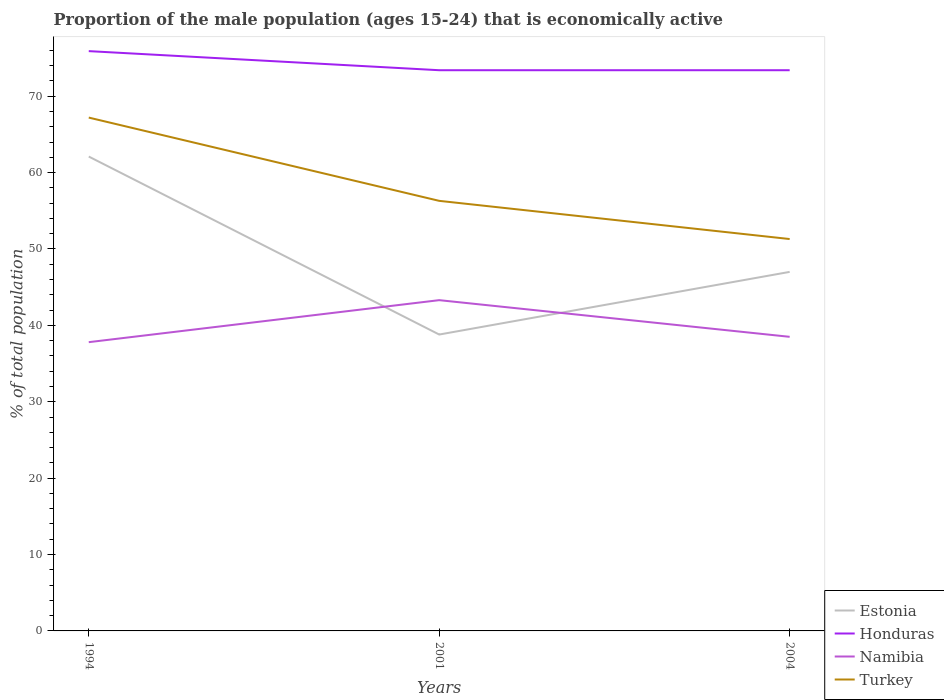How many different coloured lines are there?
Ensure brevity in your answer.  4. Across all years, what is the maximum proportion of the male population that is economically active in Namibia?
Provide a short and direct response. 37.8. In which year was the proportion of the male population that is economically active in Turkey maximum?
Make the answer very short. 2004. What is the difference between the highest and the second highest proportion of the male population that is economically active in Namibia?
Keep it short and to the point. 5.5. How many years are there in the graph?
Offer a terse response. 3. What is the difference between two consecutive major ticks on the Y-axis?
Keep it short and to the point. 10. Does the graph contain any zero values?
Provide a succinct answer. No. How many legend labels are there?
Make the answer very short. 4. How are the legend labels stacked?
Your response must be concise. Vertical. What is the title of the graph?
Your answer should be very brief. Proportion of the male population (ages 15-24) that is economically active. What is the label or title of the X-axis?
Give a very brief answer. Years. What is the label or title of the Y-axis?
Provide a succinct answer. % of total population. What is the % of total population in Estonia in 1994?
Provide a short and direct response. 62.1. What is the % of total population in Honduras in 1994?
Your response must be concise. 75.9. What is the % of total population of Namibia in 1994?
Your answer should be compact. 37.8. What is the % of total population of Turkey in 1994?
Your answer should be compact. 67.2. What is the % of total population of Estonia in 2001?
Offer a terse response. 38.8. What is the % of total population of Honduras in 2001?
Provide a succinct answer. 73.4. What is the % of total population of Namibia in 2001?
Your answer should be compact. 43.3. What is the % of total population of Turkey in 2001?
Make the answer very short. 56.3. What is the % of total population in Estonia in 2004?
Provide a short and direct response. 47. What is the % of total population of Honduras in 2004?
Your answer should be compact. 73.4. What is the % of total population of Namibia in 2004?
Make the answer very short. 38.5. What is the % of total population of Turkey in 2004?
Keep it short and to the point. 51.3. Across all years, what is the maximum % of total population of Estonia?
Provide a succinct answer. 62.1. Across all years, what is the maximum % of total population in Honduras?
Ensure brevity in your answer.  75.9. Across all years, what is the maximum % of total population of Namibia?
Keep it short and to the point. 43.3. Across all years, what is the maximum % of total population in Turkey?
Ensure brevity in your answer.  67.2. Across all years, what is the minimum % of total population of Estonia?
Offer a very short reply. 38.8. Across all years, what is the minimum % of total population in Honduras?
Keep it short and to the point. 73.4. Across all years, what is the minimum % of total population of Namibia?
Offer a terse response. 37.8. Across all years, what is the minimum % of total population of Turkey?
Your answer should be compact. 51.3. What is the total % of total population of Estonia in the graph?
Give a very brief answer. 147.9. What is the total % of total population of Honduras in the graph?
Your answer should be compact. 222.7. What is the total % of total population in Namibia in the graph?
Give a very brief answer. 119.6. What is the total % of total population of Turkey in the graph?
Provide a short and direct response. 174.8. What is the difference between the % of total population of Estonia in 1994 and that in 2001?
Offer a very short reply. 23.3. What is the difference between the % of total population in Turkey in 1994 and that in 2001?
Give a very brief answer. 10.9. What is the difference between the % of total population of Honduras in 1994 and that in 2004?
Your answer should be very brief. 2.5. What is the difference between the % of total population of Namibia in 1994 and that in 2004?
Give a very brief answer. -0.7. What is the difference between the % of total population in Turkey in 1994 and that in 2004?
Make the answer very short. 15.9. What is the difference between the % of total population in Namibia in 2001 and that in 2004?
Give a very brief answer. 4.8. What is the difference between the % of total population of Estonia in 1994 and the % of total population of Honduras in 2001?
Give a very brief answer. -11.3. What is the difference between the % of total population of Honduras in 1994 and the % of total population of Namibia in 2001?
Your answer should be very brief. 32.6. What is the difference between the % of total population in Honduras in 1994 and the % of total population in Turkey in 2001?
Offer a terse response. 19.6. What is the difference between the % of total population of Namibia in 1994 and the % of total population of Turkey in 2001?
Your answer should be very brief. -18.5. What is the difference between the % of total population in Estonia in 1994 and the % of total population in Honduras in 2004?
Provide a succinct answer. -11.3. What is the difference between the % of total population of Estonia in 1994 and the % of total population of Namibia in 2004?
Provide a short and direct response. 23.6. What is the difference between the % of total population in Honduras in 1994 and the % of total population in Namibia in 2004?
Make the answer very short. 37.4. What is the difference between the % of total population of Honduras in 1994 and the % of total population of Turkey in 2004?
Provide a short and direct response. 24.6. What is the difference between the % of total population in Namibia in 1994 and the % of total population in Turkey in 2004?
Your response must be concise. -13.5. What is the difference between the % of total population of Estonia in 2001 and the % of total population of Honduras in 2004?
Give a very brief answer. -34.6. What is the difference between the % of total population of Honduras in 2001 and the % of total population of Namibia in 2004?
Give a very brief answer. 34.9. What is the difference between the % of total population of Honduras in 2001 and the % of total population of Turkey in 2004?
Your answer should be very brief. 22.1. What is the average % of total population in Estonia per year?
Your answer should be very brief. 49.3. What is the average % of total population in Honduras per year?
Your answer should be compact. 74.23. What is the average % of total population in Namibia per year?
Provide a short and direct response. 39.87. What is the average % of total population in Turkey per year?
Offer a terse response. 58.27. In the year 1994, what is the difference between the % of total population of Estonia and % of total population of Honduras?
Give a very brief answer. -13.8. In the year 1994, what is the difference between the % of total population of Estonia and % of total population of Namibia?
Provide a short and direct response. 24.3. In the year 1994, what is the difference between the % of total population of Honduras and % of total population of Namibia?
Your answer should be compact. 38.1. In the year 1994, what is the difference between the % of total population in Honduras and % of total population in Turkey?
Your response must be concise. 8.7. In the year 1994, what is the difference between the % of total population of Namibia and % of total population of Turkey?
Keep it short and to the point. -29.4. In the year 2001, what is the difference between the % of total population in Estonia and % of total population in Honduras?
Offer a very short reply. -34.6. In the year 2001, what is the difference between the % of total population of Estonia and % of total population of Namibia?
Make the answer very short. -4.5. In the year 2001, what is the difference between the % of total population in Estonia and % of total population in Turkey?
Offer a terse response. -17.5. In the year 2001, what is the difference between the % of total population of Honduras and % of total population of Namibia?
Offer a terse response. 30.1. In the year 2001, what is the difference between the % of total population of Namibia and % of total population of Turkey?
Keep it short and to the point. -13. In the year 2004, what is the difference between the % of total population of Estonia and % of total population of Honduras?
Make the answer very short. -26.4. In the year 2004, what is the difference between the % of total population in Estonia and % of total population in Namibia?
Provide a short and direct response. 8.5. In the year 2004, what is the difference between the % of total population in Honduras and % of total population in Namibia?
Offer a terse response. 34.9. In the year 2004, what is the difference between the % of total population of Honduras and % of total population of Turkey?
Provide a succinct answer. 22.1. What is the ratio of the % of total population of Estonia in 1994 to that in 2001?
Offer a very short reply. 1.6. What is the ratio of the % of total population in Honduras in 1994 to that in 2001?
Your response must be concise. 1.03. What is the ratio of the % of total population in Namibia in 1994 to that in 2001?
Make the answer very short. 0.87. What is the ratio of the % of total population of Turkey in 1994 to that in 2001?
Your answer should be compact. 1.19. What is the ratio of the % of total population of Estonia in 1994 to that in 2004?
Offer a very short reply. 1.32. What is the ratio of the % of total population in Honduras in 1994 to that in 2004?
Ensure brevity in your answer.  1.03. What is the ratio of the % of total population of Namibia in 1994 to that in 2004?
Make the answer very short. 0.98. What is the ratio of the % of total population of Turkey in 1994 to that in 2004?
Provide a succinct answer. 1.31. What is the ratio of the % of total population of Estonia in 2001 to that in 2004?
Keep it short and to the point. 0.83. What is the ratio of the % of total population in Honduras in 2001 to that in 2004?
Offer a very short reply. 1. What is the ratio of the % of total population in Namibia in 2001 to that in 2004?
Provide a short and direct response. 1.12. What is the ratio of the % of total population in Turkey in 2001 to that in 2004?
Provide a succinct answer. 1.1. What is the difference between the highest and the second highest % of total population of Estonia?
Offer a very short reply. 15.1. What is the difference between the highest and the lowest % of total population of Estonia?
Offer a very short reply. 23.3. What is the difference between the highest and the lowest % of total population of Honduras?
Offer a terse response. 2.5. What is the difference between the highest and the lowest % of total population of Namibia?
Give a very brief answer. 5.5. 